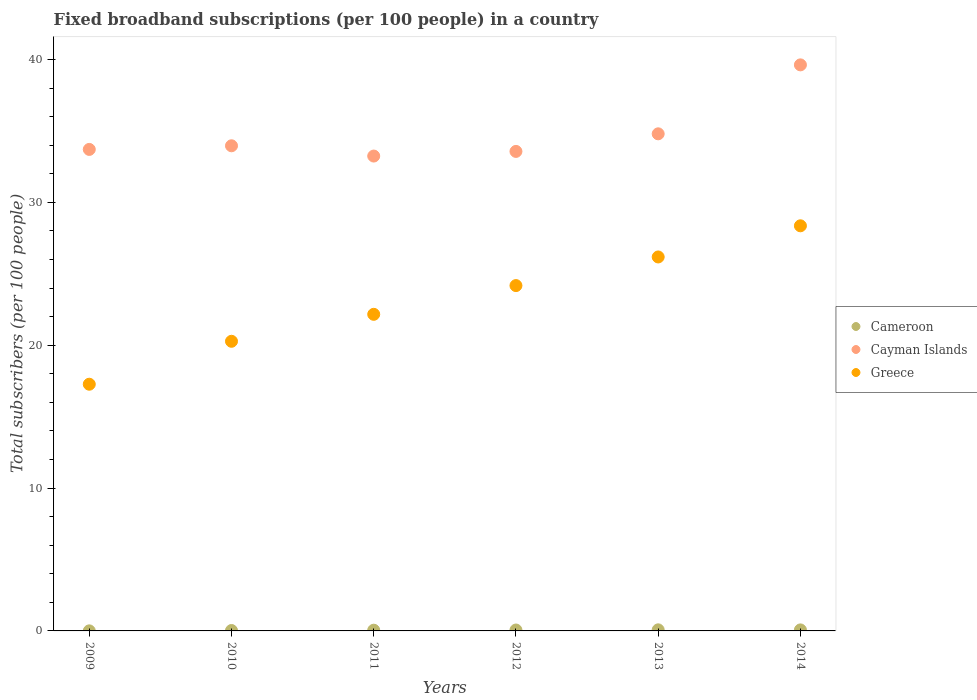How many different coloured dotlines are there?
Ensure brevity in your answer.  3. Is the number of dotlines equal to the number of legend labels?
Offer a very short reply. Yes. What is the number of broadband subscriptions in Cameroon in 2013?
Provide a short and direct response. 0.08. Across all years, what is the maximum number of broadband subscriptions in Cayman Islands?
Offer a terse response. 39.63. Across all years, what is the minimum number of broadband subscriptions in Cayman Islands?
Your answer should be very brief. 33.24. In which year was the number of broadband subscriptions in Cameroon minimum?
Keep it short and to the point. 2009. What is the total number of broadband subscriptions in Greece in the graph?
Your response must be concise. 138.42. What is the difference between the number of broadband subscriptions in Greece in 2009 and that in 2013?
Your answer should be compact. -8.91. What is the difference between the number of broadband subscriptions in Cayman Islands in 2013 and the number of broadband subscriptions in Cameroon in 2009?
Make the answer very short. 34.79. What is the average number of broadband subscriptions in Greece per year?
Offer a very short reply. 23.07. In the year 2009, what is the difference between the number of broadband subscriptions in Cameroon and number of broadband subscriptions in Greece?
Offer a terse response. -17.27. What is the ratio of the number of broadband subscriptions in Cayman Islands in 2010 to that in 2012?
Offer a very short reply. 1.01. Is the number of broadband subscriptions in Cameroon in 2009 less than that in 2013?
Offer a terse response. Yes. What is the difference between the highest and the second highest number of broadband subscriptions in Greece?
Keep it short and to the point. 2.18. What is the difference between the highest and the lowest number of broadband subscriptions in Cayman Islands?
Your answer should be very brief. 6.38. In how many years, is the number of broadband subscriptions in Greece greater than the average number of broadband subscriptions in Greece taken over all years?
Provide a short and direct response. 3. Is the sum of the number of broadband subscriptions in Greece in 2011 and 2013 greater than the maximum number of broadband subscriptions in Cayman Islands across all years?
Your answer should be very brief. Yes. Is the number of broadband subscriptions in Cameroon strictly greater than the number of broadband subscriptions in Greece over the years?
Make the answer very short. No. Is the number of broadband subscriptions in Cayman Islands strictly less than the number of broadband subscriptions in Cameroon over the years?
Your response must be concise. No. What is the difference between two consecutive major ticks on the Y-axis?
Provide a succinct answer. 10. Does the graph contain any zero values?
Make the answer very short. No. How are the legend labels stacked?
Your answer should be compact. Vertical. What is the title of the graph?
Offer a very short reply. Fixed broadband subscriptions (per 100 people) in a country. What is the label or title of the Y-axis?
Give a very brief answer. Total subscribers (per 100 people). What is the Total subscribers (per 100 people) of Cameroon in 2009?
Ensure brevity in your answer.  0. What is the Total subscribers (per 100 people) in Cayman Islands in 2009?
Your response must be concise. 33.71. What is the Total subscribers (per 100 people) of Greece in 2009?
Ensure brevity in your answer.  17.27. What is the Total subscribers (per 100 people) of Cameroon in 2010?
Provide a succinct answer. 0.03. What is the Total subscribers (per 100 people) in Cayman Islands in 2010?
Ensure brevity in your answer.  33.96. What is the Total subscribers (per 100 people) of Greece in 2010?
Keep it short and to the point. 20.28. What is the Total subscribers (per 100 people) of Cameroon in 2011?
Your answer should be compact. 0.05. What is the Total subscribers (per 100 people) of Cayman Islands in 2011?
Provide a short and direct response. 33.24. What is the Total subscribers (per 100 people) of Greece in 2011?
Provide a short and direct response. 22.16. What is the Total subscribers (per 100 people) of Cameroon in 2012?
Provide a short and direct response. 0.06. What is the Total subscribers (per 100 people) in Cayman Islands in 2012?
Ensure brevity in your answer.  33.57. What is the Total subscribers (per 100 people) of Greece in 2012?
Your answer should be very brief. 24.18. What is the Total subscribers (per 100 people) in Cameroon in 2013?
Provide a short and direct response. 0.08. What is the Total subscribers (per 100 people) in Cayman Islands in 2013?
Offer a very short reply. 34.8. What is the Total subscribers (per 100 people) in Greece in 2013?
Your answer should be compact. 26.18. What is the Total subscribers (per 100 people) in Cameroon in 2014?
Offer a very short reply. 0.07. What is the Total subscribers (per 100 people) in Cayman Islands in 2014?
Give a very brief answer. 39.63. What is the Total subscribers (per 100 people) in Greece in 2014?
Your answer should be very brief. 28.36. Across all years, what is the maximum Total subscribers (per 100 people) in Cameroon?
Provide a short and direct response. 0.08. Across all years, what is the maximum Total subscribers (per 100 people) in Cayman Islands?
Provide a short and direct response. 39.63. Across all years, what is the maximum Total subscribers (per 100 people) of Greece?
Make the answer very short. 28.36. Across all years, what is the minimum Total subscribers (per 100 people) of Cameroon?
Provide a succinct answer. 0. Across all years, what is the minimum Total subscribers (per 100 people) of Cayman Islands?
Provide a short and direct response. 33.24. Across all years, what is the minimum Total subscribers (per 100 people) in Greece?
Ensure brevity in your answer.  17.27. What is the total Total subscribers (per 100 people) in Cameroon in the graph?
Your answer should be very brief. 0.29. What is the total Total subscribers (per 100 people) in Cayman Islands in the graph?
Your answer should be compact. 208.91. What is the total Total subscribers (per 100 people) in Greece in the graph?
Your response must be concise. 138.42. What is the difference between the Total subscribers (per 100 people) in Cameroon in 2009 and that in 2010?
Your response must be concise. -0.02. What is the difference between the Total subscribers (per 100 people) of Cayman Islands in 2009 and that in 2010?
Keep it short and to the point. -0.25. What is the difference between the Total subscribers (per 100 people) in Greece in 2009 and that in 2010?
Ensure brevity in your answer.  -3.01. What is the difference between the Total subscribers (per 100 people) in Cameroon in 2009 and that in 2011?
Provide a succinct answer. -0.05. What is the difference between the Total subscribers (per 100 people) in Cayman Islands in 2009 and that in 2011?
Provide a succinct answer. 0.46. What is the difference between the Total subscribers (per 100 people) in Greece in 2009 and that in 2011?
Keep it short and to the point. -4.89. What is the difference between the Total subscribers (per 100 people) in Cameroon in 2009 and that in 2012?
Ensure brevity in your answer.  -0.06. What is the difference between the Total subscribers (per 100 people) of Cayman Islands in 2009 and that in 2012?
Provide a succinct answer. 0.14. What is the difference between the Total subscribers (per 100 people) of Greece in 2009 and that in 2012?
Your answer should be compact. -6.91. What is the difference between the Total subscribers (per 100 people) in Cameroon in 2009 and that in 2013?
Ensure brevity in your answer.  -0.07. What is the difference between the Total subscribers (per 100 people) in Cayman Islands in 2009 and that in 2013?
Make the answer very short. -1.09. What is the difference between the Total subscribers (per 100 people) of Greece in 2009 and that in 2013?
Provide a short and direct response. -8.91. What is the difference between the Total subscribers (per 100 people) in Cameroon in 2009 and that in 2014?
Your answer should be compact. -0.07. What is the difference between the Total subscribers (per 100 people) of Cayman Islands in 2009 and that in 2014?
Your answer should be compact. -5.92. What is the difference between the Total subscribers (per 100 people) of Greece in 2009 and that in 2014?
Make the answer very short. -11.09. What is the difference between the Total subscribers (per 100 people) of Cameroon in 2010 and that in 2011?
Your answer should be compact. -0.02. What is the difference between the Total subscribers (per 100 people) of Cayman Islands in 2010 and that in 2011?
Your answer should be compact. 0.72. What is the difference between the Total subscribers (per 100 people) in Greece in 2010 and that in 2011?
Offer a terse response. -1.89. What is the difference between the Total subscribers (per 100 people) of Cameroon in 2010 and that in 2012?
Your answer should be compact. -0.03. What is the difference between the Total subscribers (per 100 people) of Cayman Islands in 2010 and that in 2012?
Give a very brief answer. 0.39. What is the difference between the Total subscribers (per 100 people) of Greece in 2010 and that in 2012?
Your response must be concise. -3.9. What is the difference between the Total subscribers (per 100 people) in Cameroon in 2010 and that in 2013?
Your response must be concise. -0.05. What is the difference between the Total subscribers (per 100 people) of Cayman Islands in 2010 and that in 2013?
Offer a terse response. -0.84. What is the difference between the Total subscribers (per 100 people) of Greece in 2010 and that in 2013?
Provide a succinct answer. -5.9. What is the difference between the Total subscribers (per 100 people) of Cameroon in 2010 and that in 2014?
Your answer should be very brief. -0.04. What is the difference between the Total subscribers (per 100 people) in Cayman Islands in 2010 and that in 2014?
Provide a succinct answer. -5.66. What is the difference between the Total subscribers (per 100 people) in Greece in 2010 and that in 2014?
Offer a terse response. -8.08. What is the difference between the Total subscribers (per 100 people) in Cameroon in 2011 and that in 2012?
Give a very brief answer. -0.01. What is the difference between the Total subscribers (per 100 people) of Cayman Islands in 2011 and that in 2012?
Provide a short and direct response. -0.32. What is the difference between the Total subscribers (per 100 people) of Greece in 2011 and that in 2012?
Your answer should be very brief. -2.01. What is the difference between the Total subscribers (per 100 people) in Cameroon in 2011 and that in 2013?
Ensure brevity in your answer.  -0.03. What is the difference between the Total subscribers (per 100 people) of Cayman Islands in 2011 and that in 2013?
Provide a succinct answer. -1.56. What is the difference between the Total subscribers (per 100 people) of Greece in 2011 and that in 2013?
Provide a succinct answer. -4.02. What is the difference between the Total subscribers (per 100 people) of Cameroon in 2011 and that in 2014?
Offer a terse response. -0.02. What is the difference between the Total subscribers (per 100 people) in Cayman Islands in 2011 and that in 2014?
Your answer should be compact. -6.38. What is the difference between the Total subscribers (per 100 people) in Greece in 2011 and that in 2014?
Offer a terse response. -6.2. What is the difference between the Total subscribers (per 100 people) in Cameroon in 2012 and that in 2013?
Your response must be concise. -0.01. What is the difference between the Total subscribers (per 100 people) of Cayman Islands in 2012 and that in 2013?
Offer a terse response. -1.23. What is the difference between the Total subscribers (per 100 people) of Greece in 2012 and that in 2013?
Provide a short and direct response. -2. What is the difference between the Total subscribers (per 100 people) in Cameroon in 2012 and that in 2014?
Keep it short and to the point. -0.01. What is the difference between the Total subscribers (per 100 people) of Cayman Islands in 2012 and that in 2014?
Give a very brief answer. -6.06. What is the difference between the Total subscribers (per 100 people) in Greece in 2012 and that in 2014?
Your answer should be very brief. -4.19. What is the difference between the Total subscribers (per 100 people) in Cameroon in 2013 and that in 2014?
Provide a short and direct response. 0. What is the difference between the Total subscribers (per 100 people) of Cayman Islands in 2013 and that in 2014?
Ensure brevity in your answer.  -4.83. What is the difference between the Total subscribers (per 100 people) in Greece in 2013 and that in 2014?
Offer a terse response. -2.18. What is the difference between the Total subscribers (per 100 people) in Cameroon in 2009 and the Total subscribers (per 100 people) in Cayman Islands in 2010?
Your answer should be very brief. -33.96. What is the difference between the Total subscribers (per 100 people) of Cameroon in 2009 and the Total subscribers (per 100 people) of Greece in 2010?
Offer a very short reply. -20.27. What is the difference between the Total subscribers (per 100 people) in Cayman Islands in 2009 and the Total subscribers (per 100 people) in Greece in 2010?
Give a very brief answer. 13.43. What is the difference between the Total subscribers (per 100 people) of Cameroon in 2009 and the Total subscribers (per 100 people) of Cayman Islands in 2011?
Your response must be concise. -33.24. What is the difference between the Total subscribers (per 100 people) of Cameroon in 2009 and the Total subscribers (per 100 people) of Greece in 2011?
Make the answer very short. -22.16. What is the difference between the Total subscribers (per 100 people) of Cayman Islands in 2009 and the Total subscribers (per 100 people) of Greece in 2011?
Make the answer very short. 11.54. What is the difference between the Total subscribers (per 100 people) of Cameroon in 2009 and the Total subscribers (per 100 people) of Cayman Islands in 2012?
Your answer should be compact. -33.56. What is the difference between the Total subscribers (per 100 people) in Cameroon in 2009 and the Total subscribers (per 100 people) in Greece in 2012?
Offer a terse response. -24.17. What is the difference between the Total subscribers (per 100 people) in Cayman Islands in 2009 and the Total subscribers (per 100 people) in Greece in 2012?
Your answer should be compact. 9.53. What is the difference between the Total subscribers (per 100 people) of Cameroon in 2009 and the Total subscribers (per 100 people) of Cayman Islands in 2013?
Offer a terse response. -34.79. What is the difference between the Total subscribers (per 100 people) in Cameroon in 2009 and the Total subscribers (per 100 people) in Greece in 2013?
Give a very brief answer. -26.17. What is the difference between the Total subscribers (per 100 people) in Cayman Islands in 2009 and the Total subscribers (per 100 people) in Greece in 2013?
Keep it short and to the point. 7.53. What is the difference between the Total subscribers (per 100 people) in Cameroon in 2009 and the Total subscribers (per 100 people) in Cayman Islands in 2014?
Provide a succinct answer. -39.62. What is the difference between the Total subscribers (per 100 people) in Cameroon in 2009 and the Total subscribers (per 100 people) in Greece in 2014?
Give a very brief answer. -28.36. What is the difference between the Total subscribers (per 100 people) of Cayman Islands in 2009 and the Total subscribers (per 100 people) of Greece in 2014?
Make the answer very short. 5.35. What is the difference between the Total subscribers (per 100 people) of Cameroon in 2010 and the Total subscribers (per 100 people) of Cayman Islands in 2011?
Your response must be concise. -33.21. What is the difference between the Total subscribers (per 100 people) in Cameroon in 2010 and the Total subscribers (per 100 people) in Greece in 2011?
Your answer should be compact. -22.13. What is the difference between the Total subscribers (per 100 people) of Cayman Islands in 2010 and the Total subscribers (per 100 people) of Greece in 2011?
Offer a very short reply. 11.8. What is the difference between the Total subscribers (per 100 people) of Cameroon in 2010 and the Total subscribers (per 100 people) of Cayman Islands in 2012?
Give a very brief answer. -33.54. What is the difference between the Total subscribers (per 100 people) of Cameroon in 2010 and the Total subscribers (per 100 people) of Greece in 2012?
Keep it short and to the point. -24.15. What is the difference between the Total subscribers (per 100 people) of Cayman Islands in 2010 and the Total subscribers (per 100 people) of Greece in 2012?
Your response must be concise. 9.79. What is the difference between the Total subscribers (per 100 people) of Cameroon in 2010 and the Total subscribers (per 100 people) of Cayman Islands in 2013?
Keep it short and to the point. -34.77. What is the difference between the Total subscribers (per 100 people) of Cameroon in 2010 and the Total subscribers (per 100 people) of Greece in 2013?
Keep it short and to the point. -26.15. What is the difference between the Total subscribers (per 100 people) in Cayman Islands in 2010 and the Total subscribers (per 100 people) in Greece in 2013?
Keep it short and to the point. 7.78. What is the difference between the Total subscribers (per 100 people) in Cameroon in 2010 and the Total subscribers (per 100 people) in Cayman Islands in 2014?
Keep it short and to the point. -39.6. What is the difference between the Total subscribers (per 100 people) of Cameroon in 2010 and the Total subscribers (per 100 people) of Greece in 2014?
Provide a short and direct response. -28.33. What is the difference between the Total subscribers (per 100 people) of Cayman Islands in 2010 and the Total subscribers (per 100 people) of Greece in 2014?
Your answer should be very brief. 5.6. What is the difference between the Total subscribers (per 100 people) in Cameroon in 2011 and the Total subscribers (per 100 people) in Cayman Islands in 2012?
Keep it short and to the point. -33.52. What is the difference between the Total subscribers (per 100 people) in Cameroon in 2011 and the Total subscribers (per 100 people) in Greece in 2012?
Ensure brevity in your answer.  -24.12. What is the difference between the Total subscribers (per 100 people) of Cayman Islands in 2011 and the Total subscribers (per 100 people) of Greece in 2012?
Ensure brevity in your answer.  9.07. What is the difference between the Total subscribers (per 100 people) in Cameroon in 2011 and the Total subscribers (per 100 people) in Cayman Islands in 2013?
Provide a short and direct response. -34.75. What is the difference between the Total subscribers (per 100 people) in Cameroon in 2011 and the Total subscribers (per 100 people) in Greece in 2013?
Offer a very short reply. -26.13. What is the difference between the Total subscribers (per 100 people) in Cayman Islands in 2011 and the Total subscribers (per 100 people) in Greece in 2013?
Ensure brevity in your answer.  7.06. What is the difference between the Total subscribers (per 100 people) in Cameroon in 2011 and the Total subscribers (per 100 people) in Cayman Islands in 2014?
Give a very brief answer. -39.58. What is the difference between the Total subscribers (per 100 people) in Cameroon in 2011 and the Total subscribers (per 100 people) in Greece in 2014?
Offer a very short reply. -28.31. What is the difference between the Total subscribers (per 100 people) in Cayman Islands in 2011 and the Total subscribers (per 100 people) in Greece in 2014?
Your answer should be very brief. 4.88. What is the difference between the Total subscribers (per 100 people) of Cameroon in 2012 and the Total subscribers (per 100 people) of Cayman Islands in 2013?
Provide a succinct answer. -34.74. What is the difference between the Total subscribers (per 100 people) of Cameroon in 2012 and the Total subscribers (per 100 people) of Greece in 2013?
Your answer should be very brief. -26.12. What is the difference between the Total subscribers (per 100 people) in Cayman Islands in 2012 and the Total subscribers (per 100 people) in Greece in 2013?
Give a very brief answer. 7.39. What is the difference between the Total subscribers (per 100 people) of Cameroon in 2012 and the Total subscribers (per 100 people) of Cayman Islands in 2014?
Your answer should be compact. -39.56. What is the difference between the Total subscribers (per 100 people) in Cameroon in 2012 and the Total subscribers (per 100 people) in Greece in 2014?
Offer a terse response. -28.3. What is the difference between the Total subscribers (per 100 people) of Cayman Islands in 2012 and the Total subscribers (per 100 people) of Greece in 2014?
Your answer should be compact. 5.21. What is the difference between the Total subscribers (per 100 people) of Cameroon in 2013 and the Total subscribers (per 100 people) of Cayman Islands in 2014?
Provide a succinct answer. -39.55. What is the difference between the Total subscribers (per 100 people) of Cameroon in 2013 and the Total subscribers (per 100 people) of Greece in 2014?
Give a very brief answer. -28.28. What is the difference between the Total subscribers (per 100 people) in Cayman Islands in 2013 and the Total subscribers (per 100 people) in Greece in 2014?
Ensure brevity in your answer.  6.44. What is the average Total subscribers (per 100 people) in Cameroon per year?
Ensure brevity in your answer.  0.05. What is the average Total subscribers (per 100 people) in Cayman Islands per year?
Provide a succinct answer. 34.82. What is the average Total subscribers (per 100 people) of Greece per year?
Make the answer very short. 23.07. In the year 2009, what is the difference between the Total subscribers (per 100 people) in Cameroon and Total subscribers (per 100 people) in Cayman Islands?
Your answer should be very brief. -33.7. In the year 2009, what is the difference between the Total subscribers (per 100 people) of Cameroon and Total subscribers (per 100 people) of Greece?
Your answer should be very brief. -17.27. In the year 2009, what is the difference between the Total subscribers (per 100 people) of Cayman Islands and Total subscribers (per 100 people) of Greece?
Offer a terse response. 16.44. In the year 2010, what is the difference between the Total subscribers (per 100 people) in Cameroon and Total subscribers (per 100 people) in Cayman Islands?
Keep it short and to the point. -33.93. In the year 2010, what is the difference between the Total subscribers (per 100 people) in Cameroon and Total subscribers (per 100 people) in Greece?
Offer a very short reply. -20.25. In the year 2010, what is the difference between the Total subscribers (per 100 people) of Cayman Islands and Total subscribers (per 100 people) of Greece?
Provide a short and direct response. 13.69. In the year 2011, what is the difference between the Total subscribers (per 100 people) in Cameroon and Total subscribers (per 100 people) in Cayman Islands?
Give a very brief answer. -33.19. In the year 2011, what is the difference between the Total subscribers (per 100 people) in Cameroon and Total subscribers (per 100 people) in Greece?
Your answer should be very brief. -22.11. In the year 2011, what is the difference between the Total subscribers (per 100 people) of Cayman Islands and Total subscribers (per 100 people) of Greece?
Provide a short and direct response. 11.08. In the year 2012, what is the difference between the Total subscribers (per 100 people) in Cameroon and Total subscribers (per 100 people) in Cayman Islands?
Your response must be concise. -33.5. In the year 2012, what is the difference between the Total subscribers (per 100 people) in Cameroon and Total subscribers (per 100 people) in Greece?
Provide a short and direct response. -24.11. In the year 2012, what is the difference between the Total subscribers (per 100 people) in Cayman Islands and Total subscribers (per 100 people) in Greece?
Your response must be concise. 9.39. In the year 2013, what is the difference between the Total subscribers (per 100 people) of Cameroon and Total subscribers (per 100 people) of Cayman Islands?
Your response must be concise. -34.72. In the year 2013, what is the difference between the Total subscribers (per 100 people) of Cameroon and Total subscribers (per 100 people) of Greece?
Your answer should be very brief. -26.1. In the year 2013, what is the difference between the Total subscribers (per 100 people) in Cayman Islands and Total subscribers (per 100 people) in Greece?
Provide a succinct answer. 8.62. In the year 2014, what is the difference between the Total subscribers (per 100 people) in Cameroon and Total subscribers (per 100 people) in Cayman Islands?
Keep it short and to the point. -39.55. In the year 2014, what is the difference between the Total subscribers (per 100 people) in Cameroon and Total subscribers (per 100 people) in Greece?
Ensure brevity in your answer.  -28.29. In the year 2014, what is the difference between the Total subscribers (per 100 people) of Cayman Islands and Total subscribers (per 100 people) of Greece?
Offer a very short reply. 11.27. What is the ratio of the Total subscribers (per 100 people) of Cameroon in 2009 to that in 2010?
Your response must be concise. 0.16. What is the ratio of the Total subscribers (per 100 people) in Cayman Islands in 2009 to that in 2010?
Your response must be concise. 0.99. What is the ratio of the Total subscribers (per 100 people) in Greece in 2009 to that in 2010?
Make the answer very short. 0.85. What is the ratio of the Total subscribers (per 100 people) of Cameroon in 2009 to that in 2011?
Ensure brevity in your answer.  0.09. What is the ratio of the Total subscribers (per 100 people) of Greece in 2009 to that in 2011?
Provide a succinct answer. 0.78. What is the ratio of the Total subscribers (per 100 people) of Cameroon in 2009 to that in 2012?
Your response must be concise. 0.07. What is the ratio of the Total subscribers (per 100 people) in Cayman Islands in 2009 to that in 2012?
Make the answer very short. 1. What is the ratio of the Total subscribers (per 100 people) of Greece in 2009 to that in 2012?
Your answer should be compact. 0.71. What is the ratio of the Total subscribers (per 100 people) in Cameroon in 2009 to that in 2013?
Your response must be concise. 0.06. What is the ratio of the Total subscribers (per 100 people) of Cayman Islands in 2009 to that in 2013?
Make the answer very short. 0.97. What is the ratio of the Total subscribers (per 100 people) in Greece in 2009 to that in 2013?
Give a very brief answer. 0.66. What is the ratio of the Total subscribers (per 100 people) of Cameroon in 2009 to that in 2014?
Make the answer very short. 0.06. What is the ratio of the Total subscribers (per 100 people) of Cayman Islands in 2009 to that in 2014?
Your answer should be compact. 0.85. What is the ratio of the Total subscribers (per 100 people) in Greece in 2009 to that in 2014?
Ensure brevity in your answer.  0.61. What is the ratio of the Total subscribers (per 100 people) of Cameroon in 2010 to that in 2011?
Provide a succinct answer. 0.57. What is the ratio of the Total subscribers (per 100 people) of Cayman Islands in 2010 to that in 2011?
Give a very brief answer. 1.02. What is the ratio of the Total subscribers (per 100 people) in Greece in 2010 to that in 2011?
Offer a terse response. 0.91. What is the ratio of the Total subscribers (per 100 people) in Cameroon in 2010 to that in 2012?
Ensure brevity in your answer.  0.45. What is the ratio of the Total subscribers (per 100 people) in Cayman Islands in 2010 to that in 2012?
Give a very brief answer. 1.01. What is the ratio of the Total subscribers (per 100 people) of Greece in 2010 to that in 2012?
Make the answer very short. 0.84. What is the ratio of the Total subscribers (per 100 people) in Cameroon in 2010 to that in 2013?
Your answer should be very brief. 0.38. What is the ratio of the Total subscribers (per 100 people) of Cayman Islands in 2010 to that in 2013?
Give a very brief answer. 0.98. What is the ratio of the Total subscribers (per 100 people) in Greece in 2010 to that in 2013?
Give a very brief answer. 0.77. What is the ratio of the Total subscribers (per 100 people) of Cameroon in 2010 to that in 2014?
Your answer should be very brief. 0.41. What is the ratio of the Total subscribers (per 100 people) in Cayman Islands in 2010 to that in 2014?
Make the answer very short. 0.86. What is the ratio of the Total subscribers (per 100 people) of Greece in 2010 to that in 2014?
Ensure brevity in your answer.  0.71. What is the ratio of the Total subscribers (per 100 people) of Cameroon in 2011 to that in 2012?
Your answer should be very brief. 0.79. What is the ratio of the Total subscribers (per 100 people) in Cayman Islands in 2011 to that in 2012?
Give a very brief answer. 0.99. What is the ratio of the Total subscribers (per 100 people) of Greece in 2011 to that in 2012?
Ensure brevity in your answer.  0.92. What is the ratio of the Total subscribers (per 100 people) of Cameroon in 2011 to that in 2013?
Your response must be concise. 0.67. What is the ratio of the Total subscribers (per 100 people) in Cayman Islands in 2011 to that in 2013?
Your answer should be very brief. 0.96. What is the ratio of the Total subscribers (per 100 people) of Greece in 2011 to that in 2013?
Give a very brief answer. 0.85. What is the ratio of the Total subscribers (per 100 people) of Cameroon in 2011 to that in 2014?
Provide a succinct answer. 0.71. What is the ratio of the Total subscribers (per 100 people) in Cayman Islands in 2011 to that in 2014?
Your response must be concise. 0.84. What is the ratio of the Total subscribers (per 100 people) in Greece in 2011 to that in 2014?
Your response must be concise. 0.78. What is the ratio of the Total subscribers (per 100 people) of Cameroon in 2012 to that in 2013?
Your response must be concise. 0.84. What is the ratio of the Total subscribers (per 100 people) in Cayman Islands in 2012 to that in 2013?
Make the answer very short. 0.96. What is the ratio of the Total subscribers (per 100 people) of Greece in 2012 to that in 2013?
Provide a short and direct response. 0.92. What is the ratio of the Total subscribers (per 100 people) of Cameroon in 2012 to that in 2014?
Provide a succinct answer. 0.9. What is the ratio of the Total subscribers (per 100 people) in Cayman Islands in 2012 to that in 2014?
Your response must be concise. 0.85. What is the ratio of the Total subscribers (per 100 people) in Greece in 2012 to that in 2014?
Provide a short and direct response. 0.85. What is the ratio of the Total subscribers (per 100 people) in Cameroon in 2013 to that in 2014?
Make the answer very short. 1.07. What is the ratio of the Total subscribers (per 100 people) of Cayman Islands in 2013 to that in 2014?
Your response must be concise. 0.88. What is the difference between the highest and the second highest Total subscribers (per 100 people) in Cameroon?
Your answer should be compact. 0. What is the difference between the highest and the second highest Total subscribers (per 100 people) of Cayman Islands?
Ensure brevity in your answer.  4.83. What is the difference between the highest and the second highest Total subscribers (per 100 people) of Greece?
Your answer should be very brief. 2.18. What is the difference between the highest and the lowest Total subscribers (per 100 people) of Cameroon?
Ensure brevity in your answer.  0.07. What is the difference between the highest and the lowest Total subscribers (per 100 people) of Cayman Islands?
Provide a succinct answer. 6.38. What is the difference between the highest and the lowest Total subscribers (per 100 people) of Greece?
Your answer should be very brief. 11.09. 